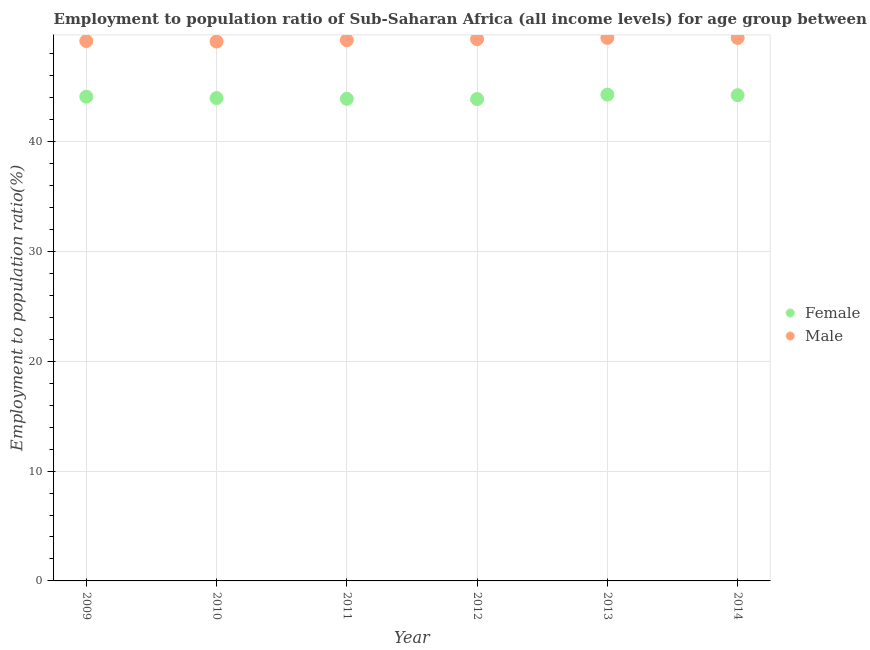What is the employment to population ratio(male) in 2009?
Offer a very short reply. 49.15. Across all years, what is the maximum employment to population ratio(female)?
Give a very brief answer. 44.27. Across all years, what is the minimum employment to population ratio(male)?
Provide a short and direct response. 49.11. In which year was the employment to population ratio(female) maximum?
Give a very brief answer. 2013. In which year was the employment to population ratio(female) minimum?
Provide a short and direct response. 2012. What is the total employment to population ratio(female) in the graph?
Provide a succinct answer. 264.28. What is the difference between the employment to population ratio(male) in 2012 and that in 2013?
Your answer should be compact. -0.12. What is the difference between the employment to population ratio(female) in 2010 and the employment to population ratio(male) in 2014?
Provide a succinct answer. -5.47. What is the average employment to population ratio(male) per year?
Give a very brief answer. 49.28. In the year 2009, what is the difference between the employment to population ratio(male) and employment to population ratio(female)?
Keep it short and to the point. 5.07. What is the ratio of the employment to population ratio(female) in 2012 to that in 2014?
Offer a terse response. 0.99. Is the employment to population ratio(female) in 2012 less than that in 2014?
Provide a succinct answer. Yes. What is the difference between the highest and the second highest employment to population ratio(female)?
Keep it short and to the point. 0.05. What is the difference between the highest and the lowest employment to population ratio(female)?
Your response must be concise. 0.4. In how many years, is the employment to population ratio(male) greater than the average employment to population ratio(male) taken over all years?
Offer a very short reply. 3. Does the employment to population ratio(female) monotonically increase over the years?
Provide a short and direct response. No. Is the employment to population ratio(male) strictly greater than the employment to population ratio(female) over the years?
Your response must be concise. Yes. Is the employment to population ratio(female) strictly less than the employment to population ratio(male) over the years?
Your answer should be compact. Yes. How many dotlines are there?
Provide a succinct answer. 2. How many years are there in the graph?
Keep it short and to the point. 6. Does the graph contain grids?
Offer a very short reply. Yes. Where does the legend appear in the graph?
Your answer should be compact. Center right. What is the title of the graph?
Keep it short and to the point. Employment to population ratio of Sub-Saharan Africa (all income levels) for age group between 15-24 years. What is the label or title of the X-axis?
Your answer should be very brief. Year. What is the Employment to population ratio(%) of Female in 2009?
Offer a very short reply. 44.08. What is the Employment to population ratio(%) of Male in 2009?
Provide a succinct answer. 49.15. What is the Employment to population ratio(%) of Female in 2010?
Your answer should be very brief. 43.96. What is the Employment to population ratio(%) in Male in 2010?
Give a very brief answer. 49.11. What is the Employment to population ratio(%) in Female in 2011?
Provide a short and direct response. 43.89. What is the Employment to population ratio(%) in Male in 2011?
Offer a very short reply. 49.23. What is the Employment to population ratio(%) of Female in 2012?
Provide a succinct answer. 43.87. What is the Employment to population ratio(%) in Male in 2012?
Offer a very short reply. 49.32. What is the Employment to population ratio(%) in Female in 2013?
Give a very brief answer. 44.27. What is the Employment to population ratio(%) of Male in 2013?
Your answer should be very brief. 49.43. What is the Employment to population ratio(%) of Female in 2014?
Your response must be concise. 44.22. What is the Employment to population ratio(%) in Male in 2014?
Give a very brief answer. 49.43. Across all years, what is the maximum Employment to population ratio(%) of Female?
Make the answer very short. 44.27. Across all years, what is the maximum Employment to population ratio(%) in Male?
Ensure brevity in your answer.  49.43. Across all years, what is the minimum Employment to population ratio(%) in Female?
Offer a very short reply. 43.87. Across all years, what is the minimum Employment to population ratio(%) in Male?
Ensure brevity in your answer.  49.11. What is the total Employment to population ratio(%) of Female in the graph?
Your response must be concise. 264.28. What is the total Employment to population ratio(%) in Male in the graph?
Your response must be concise. 295.67. What is the difference between the Employment to population ratio(%) in Female in 2009 and that in 2010?
Provide a succinct answer. 0.13. What is the difference between the Employment to population ratio(%) of Male in 2009 and that in 2010?
Make the answer very short. 0.05. What is the difference between the Employment to population ratio(%) in Female in 2009 and that in 2011?
Keep it short and to the point. 0.19. What is the difference between the Employment to population ratio(%) in Male in 2009 and that in 2011?
Make the answer very short. -0.08. What is the difference between the Employment to population ratio(%) of Female in 2009 and that in 2012?
Your response must be concise. 0.21. What is the difference between the Employment to population ratio(%) of Male in 2009 and that in 2012?
Offer a very short reply. -0.16. What is the difference between the Employment to population ratio(%) of Female in 2009 and that in 2013?
Keep it short and to the point. -0.19. What is the difference between the Employment to population ratio(%) in Male in 2009 and that in 2013?
Offer a terse response. -0.28. What is the difference between the Employment to population ratio(%) in Female in 2009 and that in 2014?
Your answer should be very brief. -0.14. What is the difference between the Employment to population ratio(%) of Male in 2009 and that in 2014?
Your response must be concise. -0.28. What is the difference between the Employment to population ratio(%) of Female in 2010 and that in 2011?
Keep it short and to the point. 0.07. What is the difference between the Employment to population ratio(%) in Male in 2010 and that in 2011?
Make the answer very short. -0.13. What is the difference between the Employment to population ratio(%) in Female in 2010 and that in 2012?
Give a very brief answer. 0.09. What is the difference between the Employment to population ratio(%) of Male in 2010 and that in 2012?
Your answer should be very brief. -0.21. What is the difference between the Employment to population ratio(%) in Female in 2010 and that in 2013?
Keep it short and to the point. -0.31. What is the difference between the Employment to population ratio(%) of Male in 2010 and that in 2013?
Your answer should be compact. -0.33. What is the difference between the Employment to population ratio(%) in Female in 2010 and that in 2014?
Offer a very short reply. -0.26. What is the difference between the Employment to population ratio(%) in Male in 2010 and that in 2014?
Your answer should be compact. -0.32. What is the difference between the Employment to population ratio(%) in Female in 2011 and that in 2012?
Provide a succinct answer. 0.02. What is the difference between the Employment to population ratio(%) in Male in 2011 and that in 2012?
Make the answer very short. -0.08. What is the difference between the Employment to population ratio(%) of Female in 2011 and that in 2013?
Keep it short and to the point. -0.38. What is the difference between the Employment to population ratio(%) in Male in 2011 and that in 2013?
Your answer should be compact. -0.2. What is the difference between the Employment to population ratio(%) of Female in 2011 and that in 2014?
Give a very brief answer. -0.33. What is the difference between the Employment to population ratio(%) of Male in 2011 and that in 2014?
Give a very brief answer. -0.2. What is the difference between the Employment to population ratio(%) in Female in 2012 and that in 2013?
Make the answer very short. -0.4. What is the difference between the Employment to population ratio(%) in Male in 2012 and that in 2013?
Your response must be concise. -0.12. What is the difference between the Employment to population ratio(%) in Female in 2012 and that in 2014?
Keep it short and to the point. -0.35. What is the difference between the Employment to population ratio(%) in Male in 2012 and that in 2014?
Provide a short and direct response. -0.11. What is the difference between the Employment to population ratio(%) of Female in 2013 and that in 2014?
Keep it short and to the point. 0.05. What is the difference between the Employment to population ratio(%) in Male in 2013 and that in 2014?
Your response must be concise. 0. What is the difference between the Employment to population ratio(%) of Female in 2009 and the Employment to population ratio(%) of Male in 2010?
Provide a short and direct response. -5.02. What is the difference between the Employment to population ratio(%) in Female in 2009 and the Employment to population ratio(%) in Male in 2011?
Offer a terse response. -5.15. What is the difference between the Employment to population ratio(%) of Female in 2009 and the Employment to population ratio(%) of Male in 2012?
Your response must be concise. -5.23. What is the difference between the Employment to population ratio(%) in Female in 2009 and the Employment to population ratio(%) in Male in 2013?
Keep it short and to the point. -5.35. What is the difference between the Employment to population ratio(%) of Female in 2009 and the Employment to population ratio(%) of Male in 2014?
Keep it short and to the point. -5.35. What is the difference between the Employment to population ratio(%) in Female in 2010 and the Employment to population ratio(%) in Male in 2011?
Offer a very short reply. -5.27. What is the difference between the Employment to population ratio(%) of Female in 2010 and the Employment to population ratio(%) of Male in 2012?
Ensure brevity in your answer.  -5.36. What is the difference between the Employment to population ratio(%) in Female in 2010 and the Employment to population ratio(%) in Male in 2013?
Provide a succinct answer. -5.47. What is the difference between the Employment to population ratio(%) in Female in 2010 and the Employment to population ratio(%) in Male in 2014?
Keep it short and to the point. -5.47. What is the difference between the Employment to population ratio(%) of Female in 2011 and the Employment to population ratio(%) of Male in 2012?
Give a very brief answer. -5.43. What is the difference between the Employment to population ratio(%) in Female in 2011 and the Employment to population ratio(%) in Male in 2013?
Provide a short and direct response. -5.54. What is the difference between the Employment to population ratio(%) of Female in 2011 and the Employment to population ratio(%) of Male in 2014?
Offer a very short reply. -5.54. What is the difference between the Employment to population ratio(%) in Female in 2012 and the Employment to population ratio(%) in Male in 2013?
Your response must be concise. -5.56. What is the difference between the Employment to population ratio(%) of Female in 2012 and the Employment to population ratio(%) of Male in 2014?
Offer a terse response. -5.56. What is the difference between the Employment to population ratio(%) of Female in 2013 and the Employment to population ratio(%) of Male in 2014?
Offer a terse response. -5.16. What is the average Employment to population ratio(%) in Female per year?
Keep it short and to the point. 44.05. What is the average Employment to population ratio(%) of Male per year?
Your answer should be very brief. 49.28. In the year 2009, what is the difference between the Employment to population ratio(%) in Female and Employment to population ratio(%) in Male?
Your response must be concise. -5.07. In the year 2010, what is the difference between the Employment to population ratio(%) of Female and Employment to population ratio(%) of Male?
Your response must be concise. -5.15. In the year 2011, what is the difference between the Employment to population ratio(%) of Female and Employment to population ratio(%) of Male?
Offer a very short reply. -5.34. In the year 2012, what is the difference between the Employment to population ratio(%) of Female and Employment to population ratio(%) of Male?
Keep it short and to the point. -5.45. In the year 2013, what is the difference between the Employment to population ratio(%) in Female and Employment to population ratio(%) in Male?
Provide a succinct answer. -5.16. In the year 2014, what is the difference between the Employment to population ratio(%) of Female and Employment to population ratio(%) of Male?
Offer a terse response. -5.21. What is the ratio of the Employment to population ratio(%) of Female in 2009 to that in 2013?
Make the answer very short. 1. What is the ratio of the Employment to population ratio(%) of Male in 2009 to that in 2013?
Give a very brief answer. 0.99. What is the ratio of the Employment to population ratio(%) in Female in 2010 to that in 2011?
Offer a very short reply. 1. What is the ratio of the Employment to population ratio(%) of Female in 2010 to that in 2012?
Ensure brevity in your answer.  1. What is the ratio of the Employment to population ratio(%) in Male in 2010 to that in 2012?
Ensure brevity in your answer.  1. What is the ratio of the Employment to population ratio(%) in Male in 2010 to that in 2014?
Offer a terse response. 0.99. What is the ratio of the Employment to population ratio(%) of Female in 2011 to that in 2012?
Offer a terse response. 1. What is the ratio of the Employment to population ratio(%) of Male in 2011 to that in 2013?
Offer a very short reply. 1. What is the ratio of the Employment to population ratio(%) of Female in 2011 to that in 2014?
Keep it short and to the point. 0.99. What is the ratio of the Employment to population ratio(%) of Female in 2012 to that in 2013?
Offer a very short reply. 0.99. What is the ratio of the Employment to population ratio(%) in Male in 2012 to that in 2013?
Give a very brief answer. 1. What is the ratio of the Employment to population ratio(%) of Female in 2012 to that in 2014?
Make the answer very short. 0.99. What is the ratio of the Employment to population ratio(%) in Male in 2012 to that in 2014?
Your answer should be very brief. 1. What is the ratio of the Employment to population ratio(%) in Female in 2013 to that in 2014?
Provide a short and direct response. 1. What is the ratio of the Employment to population ratio(%) of Male in 2013 to that in 2014?
Your answer should be very brief. 1. What is the difference between the highest and the second highest Employment to population ratio(%) in Female?
Your answer should be very brief. 0.05. What is the difference between the highest and the second highest Employment to population ratio(%) of Male?
Your response must be concise. 0. What is the difference between the highest and the lowest Employment to population ratio(%) of Female?
Provide a short and direct response. 0.4. What is the difference between the highest and the lowest Employment to population ratio(%) of Male?
Provide a short and direct response. 0.33. 